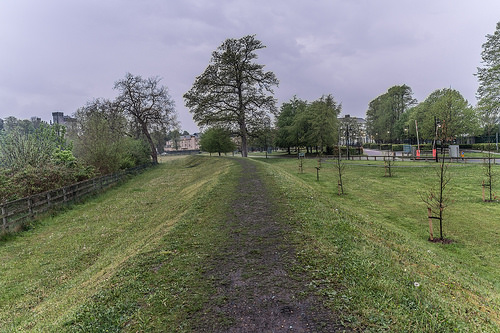<image>
Is there a tree in the ground? Yes. The tree is contained within or inside the ground, showing a containment relationship. 